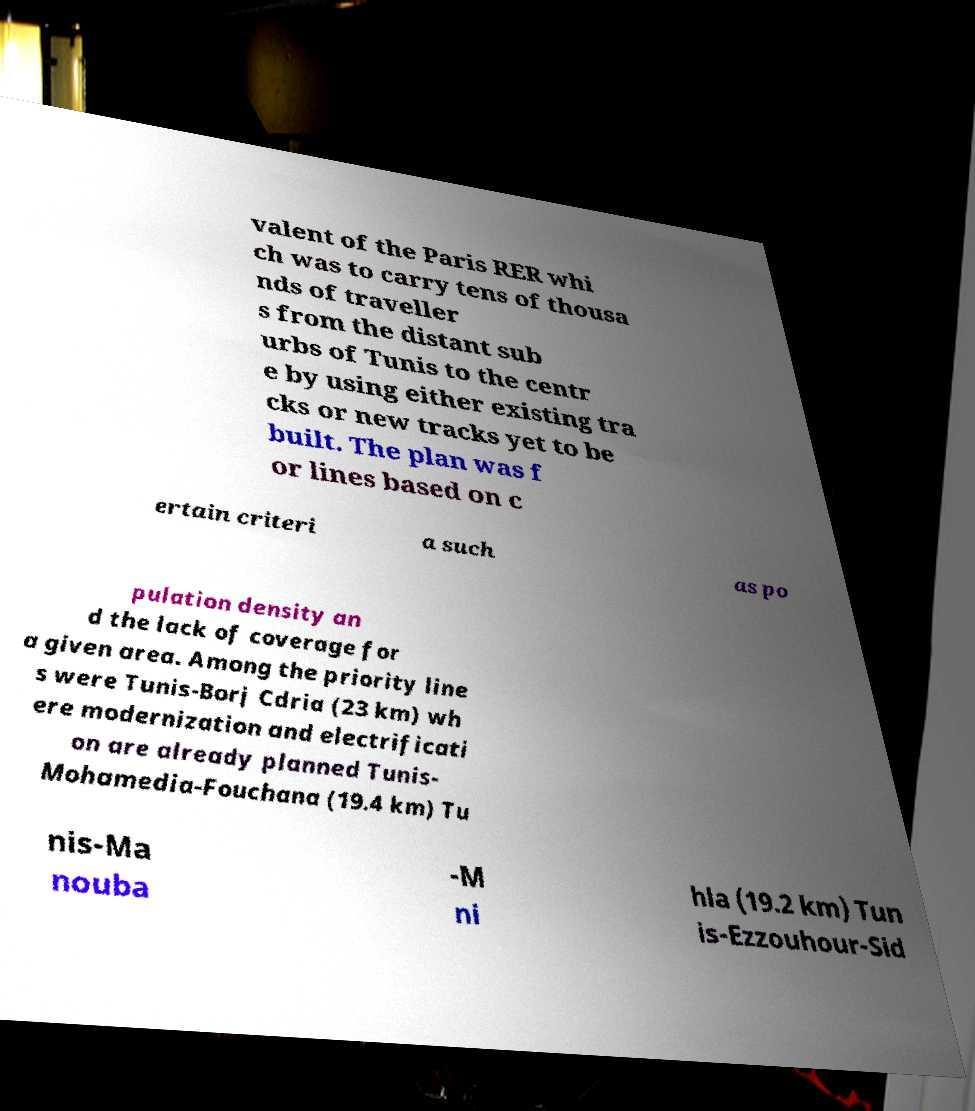For documentation purposes, I need the text within this image transcribed. Could you provide that? valent of the Paris RER whi ch was to carry tens of thousa nds of traveller s from the distant sub urbs of Tunis to the centr e by using either existing tra cks or new tracks yet to be built. The plan was f or lines based on c ertain criteri a such as po pulation density an d the lack of coverage for a given area. Among the priority line s were Tunis-Borj Cdria (23 km) wh ere modernization and electrificati on are already planned Tunis- Mohamedia-Fouchana (19.4 km) Tu nis-Ma nouba -M ni hla (19.2 km) Tun is-Ezzouhour-Sid 